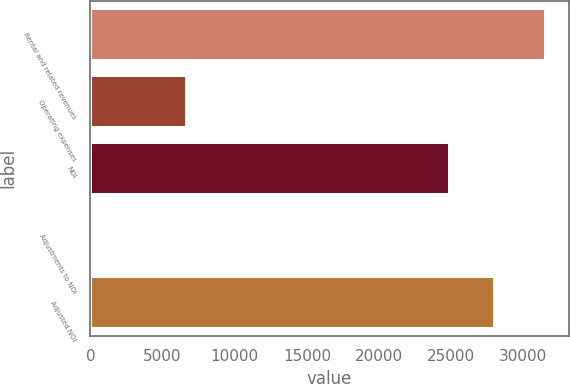<chart> <loc_0><loc_0><loc_500><loc_500><bar_chart><fcel>Rental and related revenues<fcel>Operating expenses<fcel>NOI<fcel>Adjustments to NOI<fcel>Adjusted NOI<nl><fcel>31560<fcel>6662<fcel>24898<fcel>53<fcel>28048.7<nl></chart> 